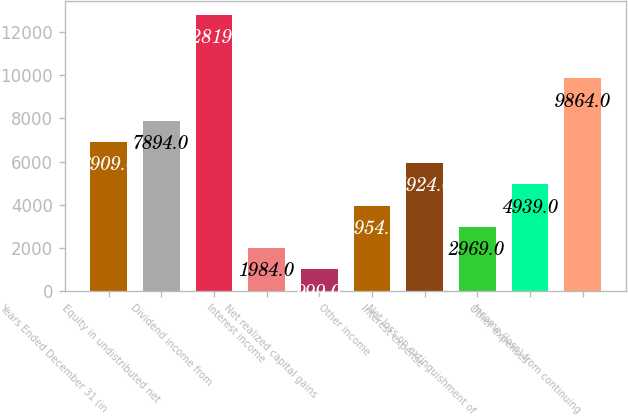<chart> <loc_0><loc_0><loc_500><loc_500><bar_chart><fcel>Years Ended December 31 (in<fcel>Equity in undistributed net<fcel>Dividend income from<fcel>Interest income<fcel>Net realized capital gains<fcel>Other income<fcel>Interest expense<fcel>Net loss on extinguishment of<fcel>Other expenses<fcel>Income (loss) from continuing<nl><fcel>6909<fcel>7894<fcel>12819<fcel>1984<fcel>999<fcel>3954<fcel>5924<fcel>2969<fcel>4939<fcel>9864<nl></chart> 